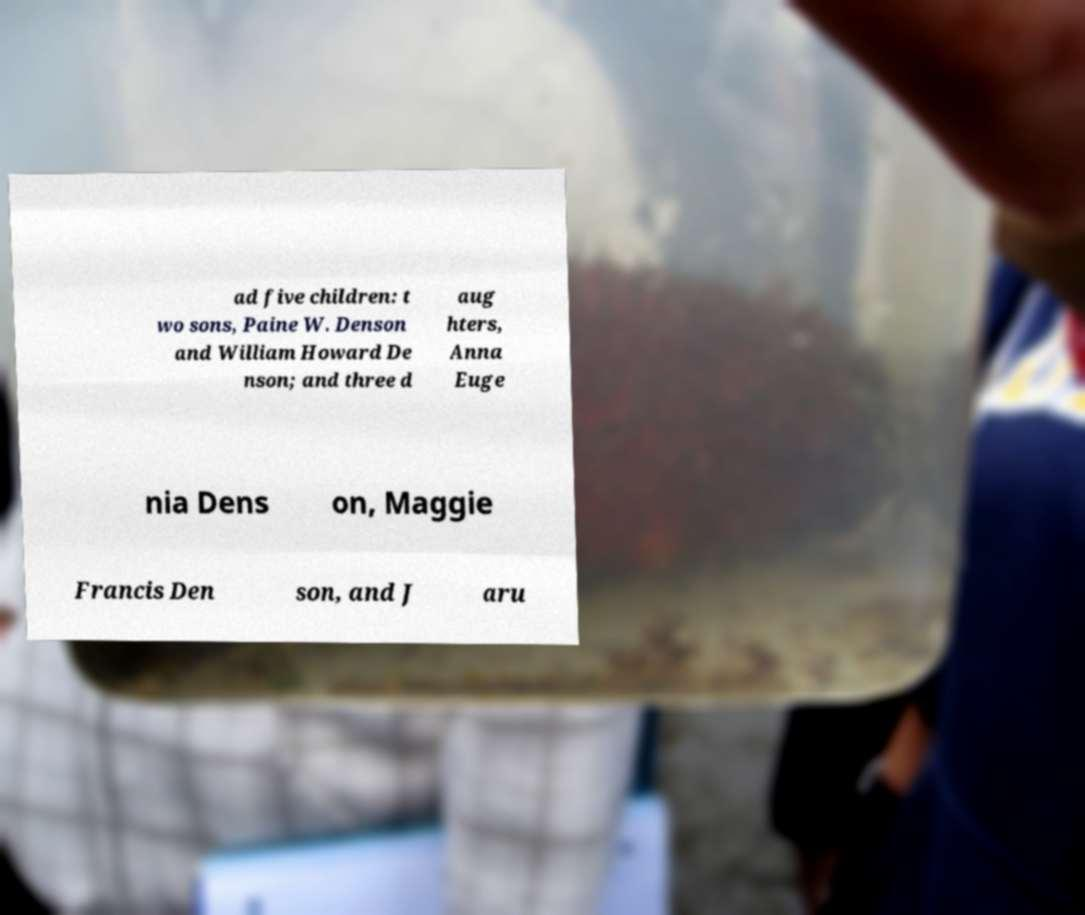There's text embedded in this image that I need extracted. Can you transcribe it verbatim? ad five children: t wo sons, Paine W. Denson and William Howard De nson; and three d aug hters, Anna Euge nia Dens on, Maggie Francis Den son, and J aru 